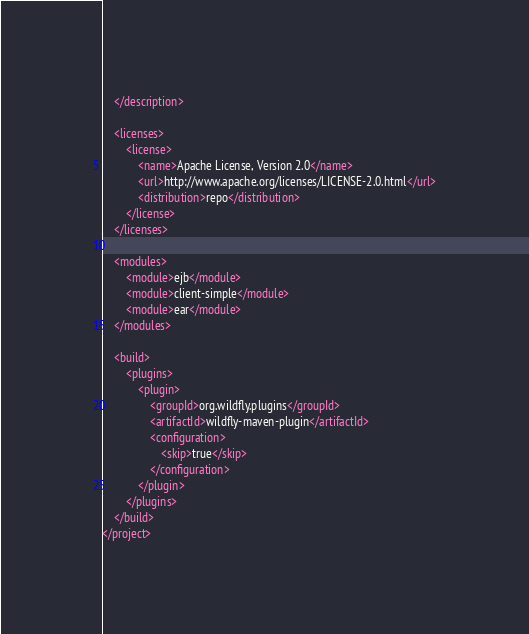<code> <loc_0><loc_0><loc_500><loc_500><_XML_>    </description>

    <licenses>
        <license>
            <name>Apache License, Version 2.0</name>
            <url>http://www.apache.org/licenses/LICENSE-2.0.html</url>
            <distribution>repo</distribution>
        </license>
    </licenses>

    <modules>
        <module>ejb</module>
        <module>client-simple</module>
        <module>ear</module>
    </modules>

    <build>
        <plugins>
            <plugin>
                <groupId>org.wildfly.plugins</groupId>
                <artifactId>wildfly-maven-plugin</artifactId>
                <configuration>
                    <skip>true</skip>
                </configuration>
            </plugin>
        </plugins>
    </build>
</project>
</code> 